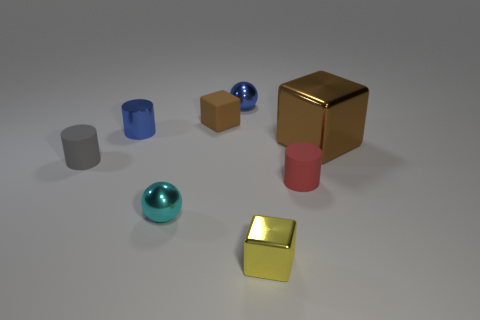Is the large shiny block the same color as the tiny rubber cube?
Offer a very short reply. Yes. What is the shape of the tiny metallic object that is both to the right of the small brown thing and in front of the tiny blue metallic ball?
Offer a very short reply. Cube. There is a small shiny ball that is on the right side of the rubber block; what color is it?
Provide a short and direct response. Blue. Is there anything else of the same color as the shiny cylinder?
Your response must be concise. Yes. Do the brown metal object and the yellow thing have the same size?
Ensure brevity in your answer.  No. There is a metallic thing that is both on the left side of the brown matte cube and behind the cyan metallic ball; how big is it?
Offer a very short reply. Small. How many things have the same material as the small blue sphere?
Provide a succinct answer. 4. What is the shape of the metal thing that is the same color as the shiny cylinder?
Offer a terse response. Sphere. The large object has what color?
Offer a very short reply. Brown. Is the shape of the small yellow thing that is on the left side of the small red rubber object the same as  the small brown matte object?
Offer a very short reply. Yes. 